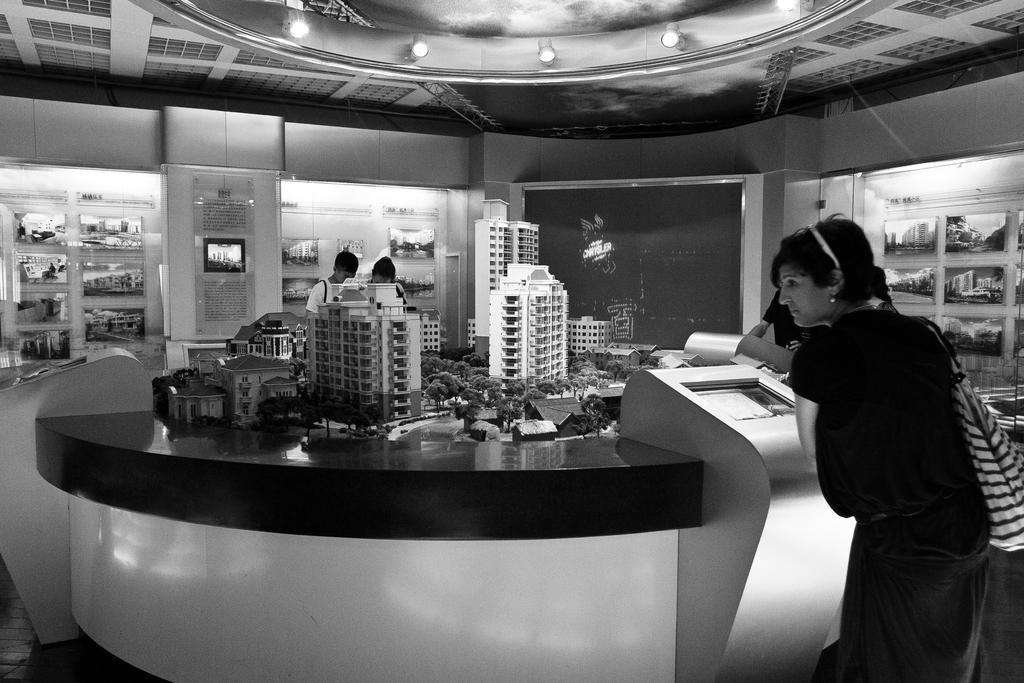How would you summarize this image in a sentence or two? In this image I can see four persons are standing on the floor in front of a cabinet on which I can see trees, houses, buildings and so on kept. In the background I can see a wall, rooftop, boards and shelves in which items are there. This image is taken may be in a hall. 